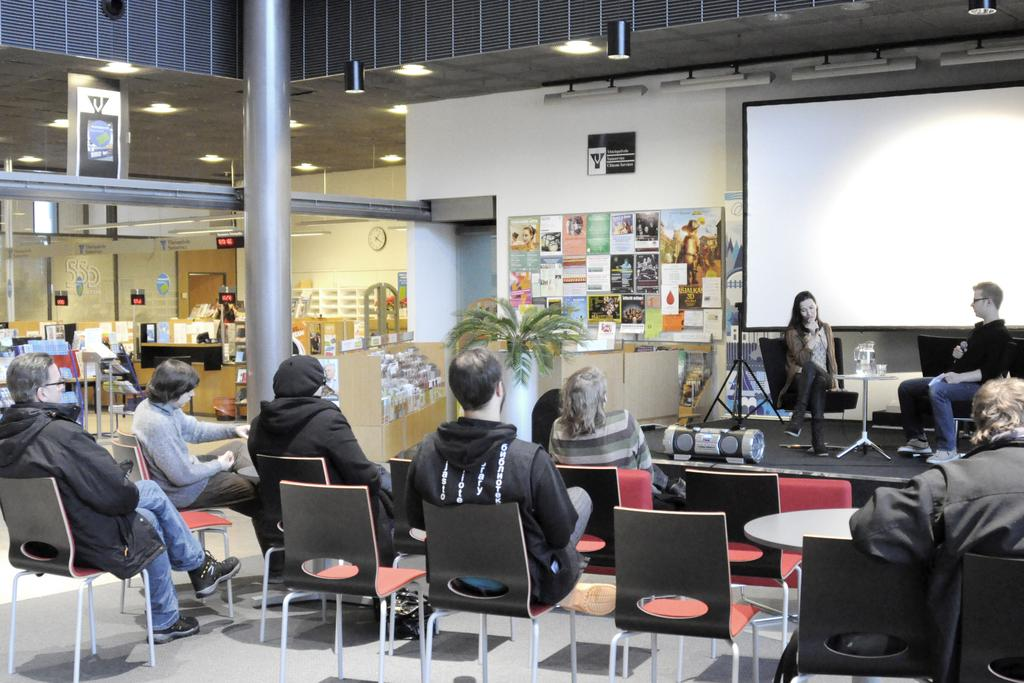What is the main subject of the image? The main subject of the image is a group of people. What are the people in the image doing? The people are sitting on chairs in the image. What object is present that might be used for displaying visuals? There is a projector in the image. What color is the wall that the projector might be projecting onto? There is a white color wall in the image. What architectural feature can be seen on the floor in the image? There is a pillar on the floor in the image. What type of drink is being passed around in the image? There is no drink being passed around in the image; the focus is on the group of people sitting on chairs and the presence of a projector and a white wall. 